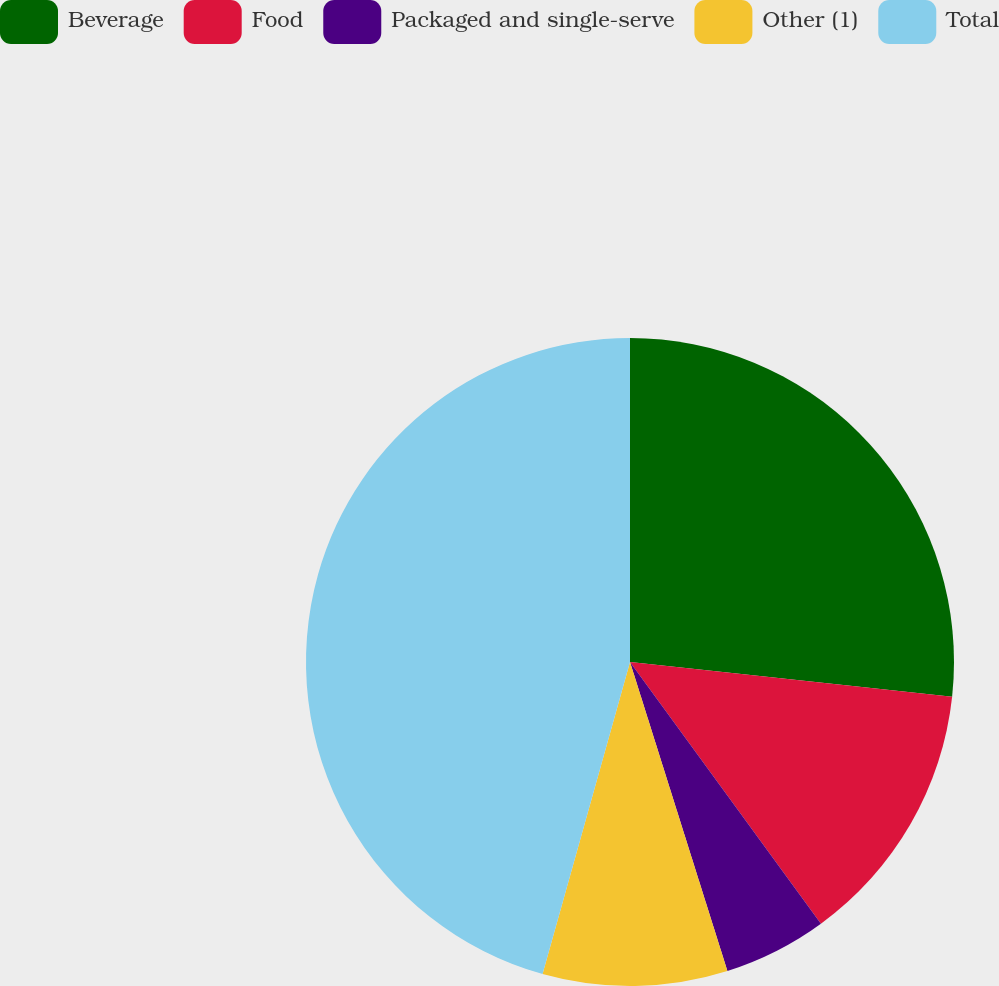Convert chart to OTSL. <chart><loc_0><loc_0><loc_500><loc_500><pie_chart><fcel>Beverage<fcel>Food<fcel>Packaged and single-serve<fcel>Other (1)<fcel>Total<nl><fcel>26.71%<fcel>13.26%<fcel>5.17%<fcel>9.21%<fcel>45.65%<nl></chart> 